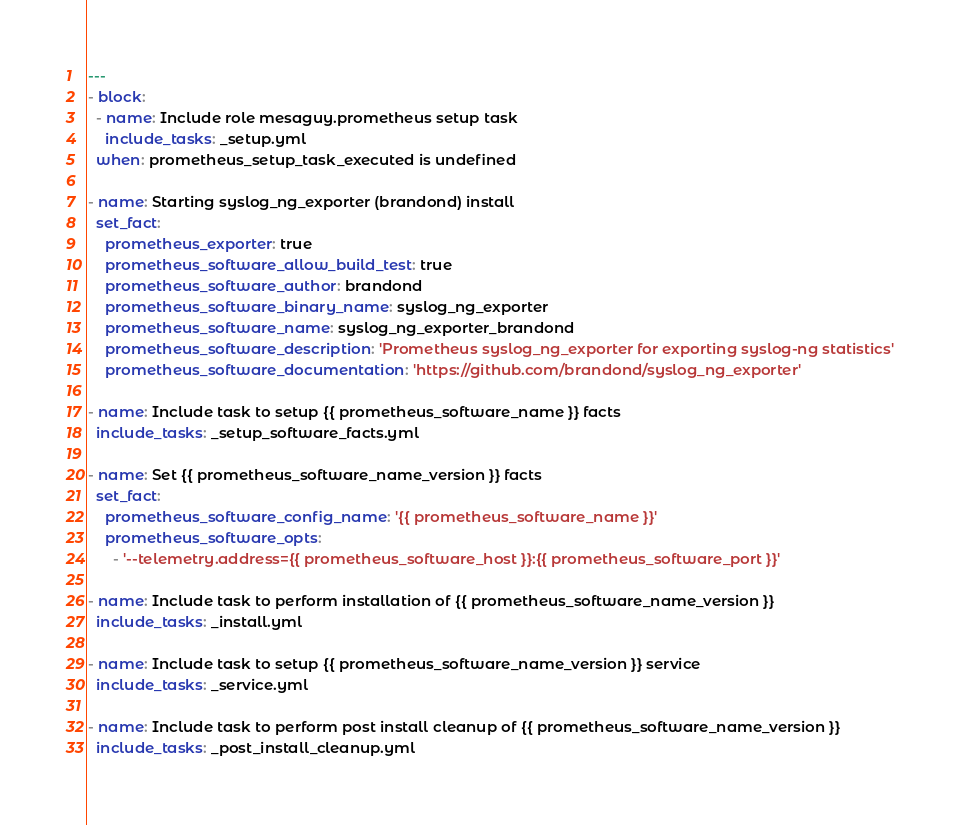<code> <loc_0><loc_0><loc_500><loc_500><_YAML_>---
- block:
  - name: Include role mesaguy.prometheus setup task
    include_tasks: _setup.yml
  when: prometheus_setup_task_executed is undefined

- name: Starting syslog_ng_exporter (brandond) install
  set_fact:
    prometheus_exporter: true
    prometheus_software_allow_build_test: true
    prometheus_software_author: brandond
    prometheus_software_binary_name: syslog_ng_exporter
    prometheus_software_name: syslog_ng_exporter_brandond
    prometheus_software_description: 'Prometheus syslog_ng_exporter for exporting syslog-ng statistics'
    prometheus_software_documentation: 'https://github.com/brandond/syslog_ng_exporter'

- name: Include task to setup {{ prometheus_software_name }} facts
  include_tasks: _setup_software_facts.yml

- name: Set {{ prometheus_software_name_version }} facts
  set_fact:
    prometheus_software_config_name: '{{ prometheus_software_name }}'
    prometheus_software_opts:
      - '--telemetry.address={{ prometheus_software_host }}:{{ prometheus_software_port }}'

- name: Include task to perform installation of {{ prometheus_software_name_version }}
  include_tasks: _install.yml

- name: Include task to setup {{ prometheus_software_name_version }} service
  include_tasks: _service.yml

- name: Include task to perform post install cleanup of {{ prometheus_software_name_version }}
  include_tasks: _post_install_cleanup.yml
</code> 